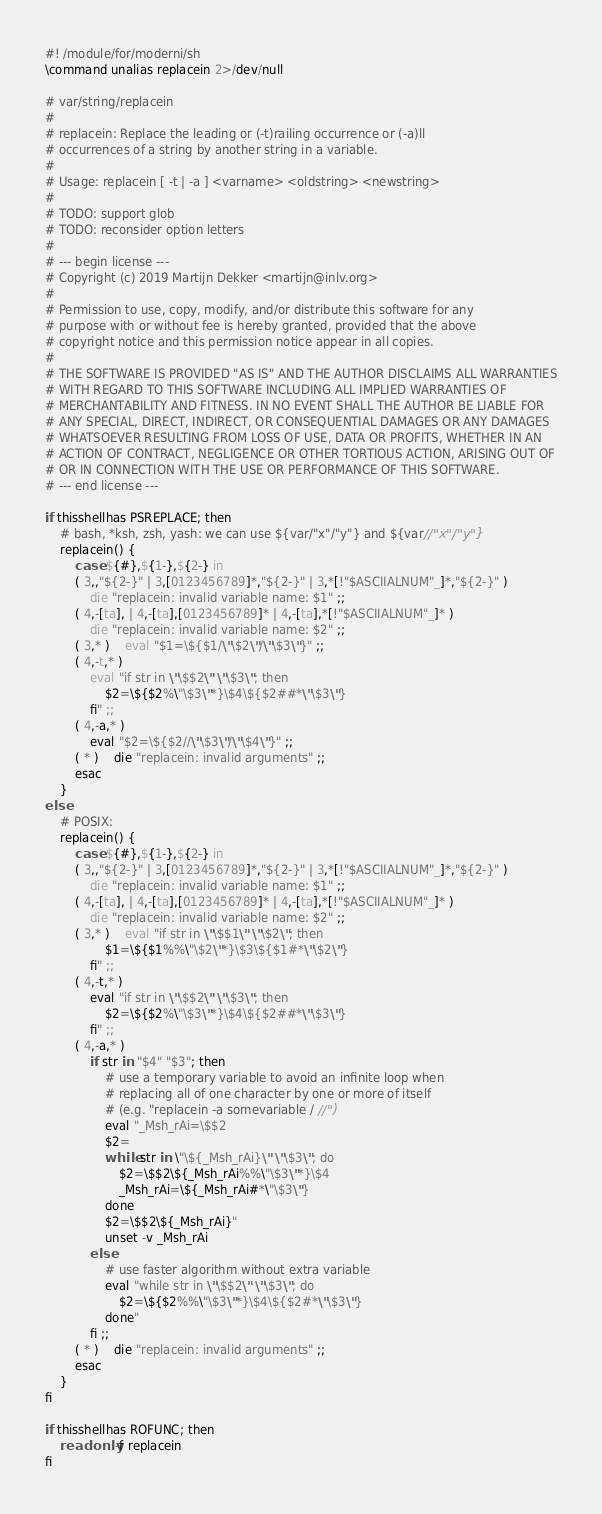Convert code to text. <code><loc_0><loc_0><loc_500><loc_500><_ObjectiveC_>#! /module/for/moderni/sh
\command unalias replacein 2>/dev/null

# var/string/replacein
#
# replacein: Replace the leading or (-t)railing occurrence or (-a)ll
# occurrences of a string by another string in a variable.
#
# Usage: replacein [ -t | -a ] <varname> <oldstring> <newstring>
#
# TODO: support glob
# TODO: reconsider option letters
#
# --- begin license ---
# Copyright (c) 2019 Martijn Dekker <martijn@inlv.org>
#
# Permission to use, copy, modify, and/or distribute this software for any
# purpose with or without fee is hereby granted, provided that the above
# copyright notice and this permission notice appear in all copies.
#
# THE SOFTWARE IS PROVIDED "AS IS" AND THE AUTHOR DISCLAIMS ALL WARRANTIES
# WITH REGARD TO THIS SOFTWARE INCLUDING ALL IMPLIED WARRANTIES OF
# MERCHANTABILITY AND FITNESS. IN NO EVENT SHALL THE AUTHOR BE LIABLE FOR
# ANY SPECIAL, DIRECT, INDIRECT, OR CONSEQUENTIAL DAMAGES OR ANY DAMAGES
# WHATSOEVER RESULTING FROM LOSS OF USE, DATA OR PROFITS, WHETHER IN AN
# ACTION OF CONTRACT, NEGLIGENCE OR OTHER TORTIOUS ACTION, ARISING OUT OF
# OR IN CONNECTION WITH THE USE OR PERFORMANCE OF THIS SOFTWARE.
# --- end license ---

if thisshellhas PSREPLACE; then
	# bash, *ksh, zsh, yash: we can use ${var/"x"/"y"} and ${var//"x"/"y"}
	replacein() {
		case ${#},${1-},${2-} in
		( 3,,"${2-}" | 3,[0123456789]*,"${2-}" | 3,*[!"$ASCIIALNUM"_]*,"${2-}" )
			die "replacein: invalid variable name: $1" ;;
		( 4,-[ta], | 4,-[ta],[0123456789]* | 4,-[ta],*[!"$ASCIIALNUM"_]* )
			die "replacein: invalid variable name: $2" ;;
		( 3,* )	eval "$1=\${$1/\"\$2\"/\"\$3\"}" ;;
		( 4,-t,* )
			eval "if str in \"\$$2\" \"\$3\"; then
				$2=\${$2%\"\$3\"*}\$4\${$2##*\"\$3\"}
			fi" ;;
		( 4,-a,* )
			eval "$2=\${$2//\"\$3\"/\"\$4\"}" ;;
		( * )	die "replacein: invalid arguments" ;;
		esac
	}
else
	# POSIX:
	replacein() {
		case ${#},${1-},${2-} in
		( 3,,"${2-}" | 3,[0123456789]*,"${2-}" | 3,*[!"$ASCIIALNUM"_]*,"${2-}" )
			die "replacein: invalid variable name: $1" ;;
		( 4,-[ta], | 4,-[ta],[0123456789]* | 4,-[ta],*[!"$ASCIIALNUM"_]* )
			die "replacein: invalid variable name: $2" ;;
		( 3,* )	eval "if str in \"\$$1\" \"\$2\"; then
				$1=\${$1%%\"\$2\"*}\$3\${$1#*\"\$2\"}
			fi" ;;
		( 4,-t,* )
			eval "if str in \"\$$2\" \"\$3\"; then
				$2=\${$2%\"\$3\"*}\$4\${$2##*\"\$3\"}
			fi" ;;
		( 4,-a,* )
			if str in "$4" "$3"; then
				# use a temporary variable to avoid an infinite loop when
				# replacing all of one character by one or more of itself
				# (e.g. "replacein -a somevariable / //")
				eval "_Msh_rAi=\$$2
				$2=
				while str in \"\${_Msh_rAi}\" \"\$3\"; do
					$2=\$$2\${_Msh_rAi%%\"\$3\"*}\$4
					_Msh_rAi=\${_Msh_rAi#*\"\$3\"}
				done
				$2=\$$2\${_Msh_rAi}"
				unset -v _Msh_rAi
			else
				# use faster algorithm without extra variable
				eval "while str in \"\$$2\" \"\$3\"; do
					$2=\${$2%%\"\$3\"*}\$4\${$2#*\"\$3\"}
				done"
			fi ;;
		( * )	die "replacein: invalid arguments" ;;
		esac
	}
fi

if thisshellhas ROFUNC; then
	readonly -f replacein
fi
</code> 